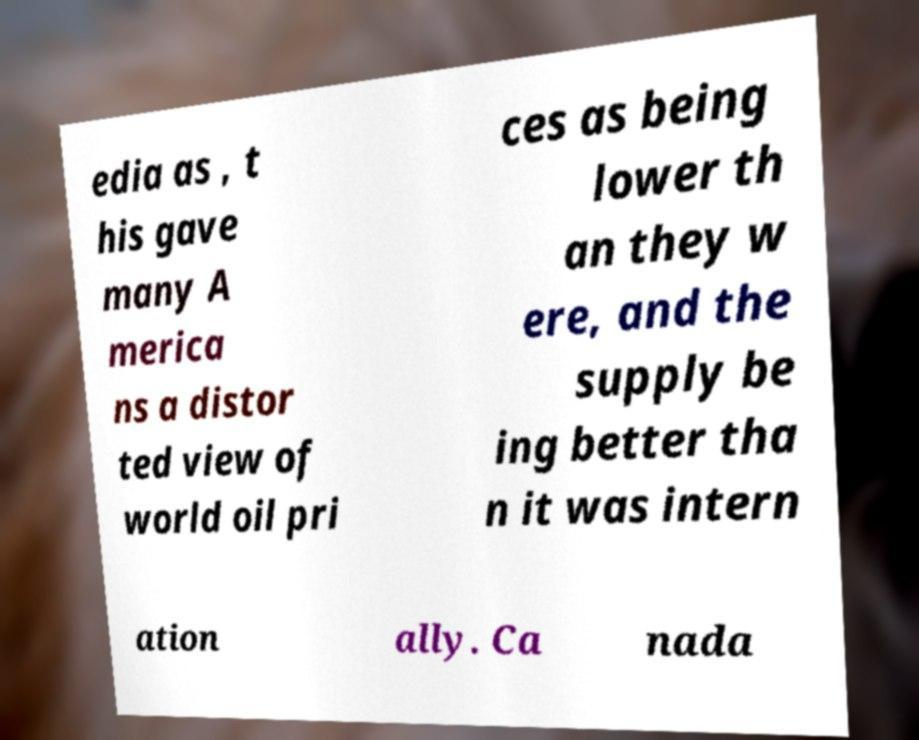Please read and relay the text visible in this image. What does it say? edia as , t his gave many A merica ns a distor ted view of world oil pri ces as being lower th an they w ere, and the supply be ing better tha n it was intern ation ally. Ca nada 